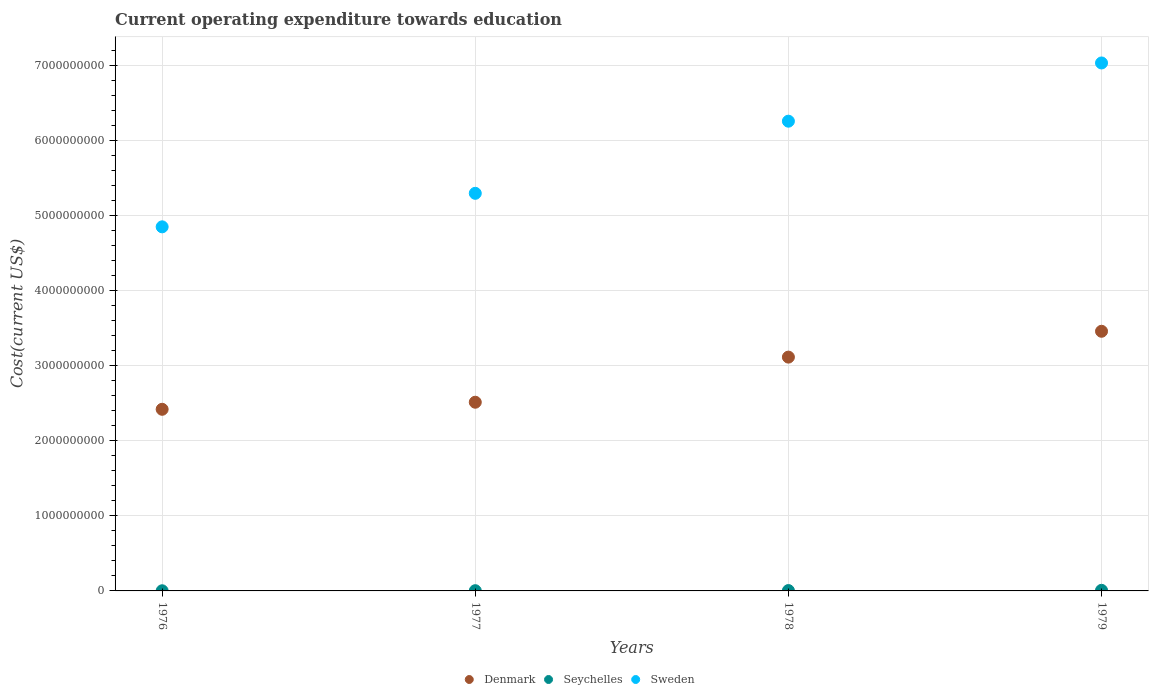What is the expenditure towards education in Seychelles in 1977?
Keep it short and to the point. 3.05e+06. Across all years, what is the maximum expenditure towards education in Denmark?
Offer a terse response. 3.46e+09. Across all years, what is the minimum expenditure towards education in Sweden?
Your answer should be very brief. 4.85e+09. In which year was the expenditure towards education in Seychelles maximum?
Give a very brief answer. 1979. In which year was the expenditure towards education in Denmark minimum?
Provide a short and direct response. 1976. What is the total expenditure towards education in Denmark in the graph?
Offer a terse response. 1.15e+1. What is the difference between the expenditure towards education in Seychelles in 1977 and that in 1979?
Provide a succinct answer. -4.85e+06. What is the difference between the expenditure towards education in Denmark in 1978 and the expenditure towards education in Sweden in 1976?
Ensure brevity in your answer.  -1.73e+09. What is the average expenditure towards education in Seychelles per year?
Keep it short and to the point. 4.40e+06. In the year 1978, what is the difference between the expenditure towards education in Seychelles and expenditure towards education in Sweden?
Provide a short and direct response. -6.25e+09. What is the ratio of the expenditure towards education in Denmark in 1976 to that in 1977?
Make the answer very short. 0.96. What is the difference between the highest and the second highest expenditure towards education in Sweden?
Offer a very short reply. 7.75e+08. What is the difference between the highest and the lowest expenditure towards education in Seychelles?
Give a very brief answer. 5.92e+06. Is the sum of the expenditure towards education in Seychelles in 1977 and 1978 greater than the maximum expenditure towards education in Denmark across all years?
Make the answer very short. No. Is the expenditure towards education in Seychelles strictly greater than the expenditure towards education in Denmark over the years?
Your response must be concise. No. Are the values on the major ticks of Y-axis written in scientific E-notation?
Your answer should be compact. No. Does the graph contain any zero values?
Keep it short and to the point. No. Does the graph contain grids?
Keep it short and to the point. Yes. Where does the legend appear in the graph?
Your answer should be compact. Bottom center. How many legend labels are there?
Provide a short and direct response. 3. What is the title of the graph?
Your response must be concise. Current operating expenditure towards education. What is the label or title of the X-axis?
Provide a short and direct response. Years. What is the label or title of the Y-axis?
Keep it short and to the point. Cost(current US$). What is the Cost(current US$) of Denmark in 1976?
Offer a very short reply. 2.42e+09. What is the Cost(current US$) in Seychelles in 1976?
Provide a short and direct response. 1.98e+06. What is the Cost(current US$) of Sweden in 1976?
Keep it short and to the point. 4.85e+09. What is the Cost(current US$) of Denmark in 1977?
Provide a short and direct response. 2.51e+09. What is the Cost(current US$) of Seychelles in 1977?
Provide a succinct answer. 3.05e+06. What is the Cost(current US$) of Sweden in 1977?
Offer a terse response. 5.29e+09. What is the Cost(current US$) of Denmark in 1978?
Provide a succinct answer. 3.11e+09. What is the Cost(current US$) of Seychelles in 1978?
Your response must be concise. 4.68e+06. What is the Cost(current US$) in Sweden in 1978?
Make the answer very short. 6.26e+09. What is the Cost(current US$) of Denmark in 1979?
Your answer should be compact. 3.46e+09. What is the Cost(current US$) of Seychelles in 1979?
Provide a succinct answer. 7.90e+06. What is the Cost(current US$) of Sweden in 1979?
Keep it short and to the point. 7.03e+09. Across all years, what is the maximum Cost(current US$) in Denmark?
Make the answer very short. 3.46e+09. Across all years, what is the maximum Cost(current US$) of Seychelles?
Your answer should be compact. 7.90e+06. Across all years, what is the maximum Cost(current US$) of Sweden?
Ensure brevity in your answer.  7.03e+09. Across all years, what is the minimum Cost(current US$) in Denmark?
Your response must be concise. 2.42e+09. Across all years, what is the minimum Cost(current US$) of Seychelles?
Give a very brief answer. 1.98e+06. Across all years, what is the minimum Cost(current US$) of Sweden?
Keep it short and to the point. 4.85e+09. What is the total Cost(current US$) of Denmark in the graph?
Provide a succinct answer. 1.15e+1. What is the total Cost(current US$) of Seychelles in the graph?
Keep it short and to the point. 1.76e+07. What is the total Cost(current US$) in Sweden in the graph?
Provide a short and direct response. 2.34e+1. What is the difference between the Cost(current US$) in Denmark in 1976 and that in 1977?
Provide a succinct answer. -9.41e+07. What is the difference between the Cost(current US$) of Seychelles in 1976 and that in 1977?
Provide a short and direct response. -1.07e+06. What is the difference between the Cost(current US$) in Sweden in 1976 and that in 1977?
Ensure brevity in your answer.  -4.46e+08. What is the difference between the Cost(current US$) in Denmark in 1976 and that in 1978?
Your answer should be compact. -6.95e+08. What is the difference between the Cost(current US$) in Seychelles in 1976 and that in 1978?
Give a very brief answer. -2.70e+06. What is the difference between the Cost(current US$) of Sweden in 1976 and that in 1978?
Your answer should be very brief. -1.41e+09. What is the difference between the Cost(current US$) of Denmark in 1976 and that in 1979?
Your answer should be compact. -1.04e+09. What is the difference between the Cost(current US$) of Seychelles in 1976 and that in 1979?
Provide a short and direct response. -5.92e+06. What is the difference between the Cost(current US$) of Sweden in 1976 and that in 1979?
Give a very brief answer. -2.18e+09. What is the difference between the Cost(current US$) in Denmark in 1977 and that in 1978?
Provide a short and direct response. -6.01e+08. What is the difference between the Cost(current US$) in Seychelles in 1977 and that in 1978?
Provide a short and direct response. -1.63e+06. What is the difference between the Cost(current US$) in Sweden in 1977 and that in 1978?
Make the answer very short. -9.61e+08. What is the difference between the Cost(current US$) of Denmark in 1977 and that in 1979?
Your answer should be very brief. -9.45e+08. What is the difference between the Cost(current US$) of Seychelles in 1977 and that in 1979?
Give a very brief answer. -4.85e+06. What is the difference between the Cost(current US$) of Sweden in 1977 and that in 1979?
Provide a succinct answer. -1.74e+09. What is the difference between the Cost(current US$) of Denmark in 1978 and that in 1979?
Give a very brief answer. -3.44e+08. What is the difference between the Cost(current US$) of Seychelles in 1978 and that in 1979?
Ensure brevity in your answer.  -3.22e+06. What is the difference between the Cost(current US$) in Sweden in 1978 and that in 1979?
Keep it short and to the point. -7.75e+08. What is the difference between the Cost(current US$) in Denmark in 1976 and the Cost(current US$) in Seychelles in 1977?
Keep it short and to the point. 2.42e+09. What is the difference between the Cost(current US$) in Denmark in 1976 and the Cost(current US$) in Sweden in 1977?
Provide a succinct answer. -2.88e+09. What is the difference between the Cost(current US$) of Seychelles in 1976 and the Cost(current US$) of Sweden in 1977?
Offer a terse response. -5.29e+09. What is the difference between the Cost(current US$) of Denmark in 1976 and the Cost(current US$) of Seychelles in 1978?
Keep it short and to the point. 2.41e+09. What is the difference between the Cost(current US$) of Denmark in 1976 and the Cost(current US$) of Sweden in 1978?
Your response must be concise. -3.84e+09. What is the difference between the Cost(current US$) of Seychelles in 1976 and the Cost(current US$) of Sweden in 1978?
Provide a succinct answer. -6.25e+09. What is the difference between the Cost(current US$) in Denmark in 1976 and the Cost(current US$) in Seychelles in 1979?
Keep it short and to the point. 2.41e+09. What is the difference between the Cost(current US$) of Denmark in 1976 and the Cost(current US$) of Sweden in 1979?
Provide a succinct answer. -4.61e+09. What is the difference between the Cost(current US$) of Seychelles in 1976 and the Cost(current US$) of Sweden in 1979?
Offer a terse response. -7.03e+09. What is the difference between the Cost(current US$) in Denmark in 1977 and the Cost(current US$) in Seychelles in 1978?
Offer a terse response. 2.51e+09. What is the difference between the Cost(current US$) of Denmark in 1977 and the Cost(current US$) of Sweden in 1978?
Your response must be concise. -3.74e+09. What is the difference between the Cost(current US$) in Seychelles in 1977 and the Cost(current US$) in Sweden in 1978?
Your response must be concise. -6.25e+09. What is the difference between the Cost(current US$) in Denmark in 1977 and the Cost(current US$) in Seychelles in 1979?
Give a very brief answer. 2.50e+09. What is the difference between the Cost(current US$) in Denmark in 1977 and the Cost(current US$) in Sweden in 1979?
Ensure brevity in your answer.  -4.52e+09. What is the difference between the Cost(current US$) in Seychelles in 1977 and the Cost(current US$) in Sweden in 1979?
Your response must be concise. -7.03e+09. What is the difference between the Cost(current US$) of Denmark in 1978 and the Cost(current US$) of Seychelles in 1979?
Make the answer very short. 3.11e+09. What is the difference between the Cost(current US$) in Denmark in 1978 and the Cost(current US$) in Sweden in 1979?
Offer a terse response. -3.92e+09. What is the difference between the Cost(current US$) in Seychelles in 1978 and the Cost(current US$) in Sweden in 1979?
Your answer should be very brief. -7.03e+09. What is the average Cost(current US$) of Denmark per year?
Your answer should be very brief. 2.88e+09. What is the average Cost(current US$) of Seychelles per year?
Offer a terse response. 4.40e+06. What is the average Cost(current US$) in Sweden per year?
Keep it short and to the point. 5.86e+09. In the year 1976, what is the difference between the Cost(current US$) of Denmark and Cost(current US$) of Seychelles?
Give a very brief answer. 2.42e+09. In the year 1976, what is the difference between the Cost(current US$) of Denmark and Cost(current US$) of Sweden?
Provide a short and direct response. -2.43e+09. In the year 1976, what is the difference between the Cost(current US$) of Seychelles and Cost(current US$) of Sweden?
Offer a terse response. -4.85e+09. In the year 1977, what is the difference between the Cost(current US$) of Denmark and Cost(current US$) of Seychelles?
Give a very brief answer. 2.51e+09. In the year 1977, what is the difference between the Cost(current US$) in Denmark and Cost(current US$) in Sweden?
Provide a short and direct response. -2.78e+09. In the year 1977, what is the difference between the Cost(current US$) in Seychelles and Cost(current US$) in Sweden?
Your answer should be very brief. -5.29e+09. In the year 1978, what is the difference between the Cost(current US$) in Denmark and Cost(current US$) in Seychelles?
Offer a very short reply. 3.11e+09. In the year 1978, what is the difference between the Cost(current US$) of Denmark and Cost(current US$) of Sweden?
Your answer should be compact. -3.14e+09. In the year 1978, what is the difference between the Cost(current US$) of Seychelles and Cost(current US$) of Sweden?
Offer a very short reply. -6.25e+09. In the year 1979, what is the difference between the Cost(current US$) of Denmark and Cost(current US$) of Seychelles?
Provide a succinct answer. 3.45e+09. In the year 1979, what is the difference between the Cost(current US$) of Denmark and Cost(current US$) of Sweden?
Your answer should be compact. -3.57e+09. In the year 1979, what is the difference between the Cost(current US$) of Seychelles and Cost(current US$) of Sweden?
Keep it short and to the point. -7.02e+09. What is the ratio of the Cost(current US$) in Denmark in 1976 to that in 1977?
Offer a very short reply. 0.96. What is the ratio of the Cost(current US$) of Seychelles in 1976 to that in 1977?
Make the answer very short. 0.65. What is the ratio of the Cost(current US$) in Sweden in 1976 to that in 1977?
Provide a short and direct response. 0.92. What is the ratio of the Cost(current US$) of Denmark in 1976 to that in 1978?
Give a very brief answer. 0.78. What is the ratio of the Cost(current US$) in Seychelles in 1976 to that in 1978?
Your answer should be compact. 0.42. What is the ratio of the Cost(current US$) in Sweden in 1976 to that in 1978?
Give a very brief answer. 0.78. What is the ratio of the Cost(current US$) in Denmark in 1976 to that in 1979?
Keep it short and to the point. 0.7. What is the ratio of the Cost(current US$) in Seychelles in 1976 to that in 1979?
Provide a short and direct response. 0.25. What is the ratio of the Cost(current US$) in Sweden in 1976 to that in 1979?
Offer a very short reply. 0.69. What is the ratio of the Cost(current US$) in Denmark in 1977 to that in 1978?
Ensure brevity in your answer.  0.81. What is the ratio of the Cost(current US$) of Seychelles in 1977 to that in 1978?
Keep it short and to the point. 0.65. What is the ratio of the Cost(current US$) in Sweden in 1977 to that in 1978?
Keep it short and to the point. 0.85. What is the ratio of the Cost(current US$) of Denmark in 1977 to that in 1979?
Give a very brief answer. 0.73. What is the ratio of the Cost(current US$) in Seychelles in 1977 to that in 1979?
Your answer should be very brief. 0.39. What is the ratio of the Cost(current US$) of Sweden in 1977 to that in 1979?
Offer a terse response. 0.75. What is the ratio of the Cost(current US$) of Denmark in 1978 to that in 1979?
Keep it short and to the point. 0.9. What is the ratio of the Cost(current US$) in Seychelles in 1978 to that in 1979?
Offer a very short reply. 0.59. What is the ratio of the Cost(current US$) of Sweden in 1978 to that in 1979?
Ensure brevity in your answer.  0.89. What is the difference between the highest and the second highest Cost(current US$) of Denmark?
Your response must be concise. 3.44e+08. What is the difference between the highest and the second highest Cost(current US$) in Seychelles?
Your answer should be very brief. 3.22e+06. What is the difference between the highest and the second highest Cost(current US$) of Sweden?
Keep it short and to the point. 7.75e+08. What is the difference between the highest and the lowest Cost(current US$) in Denmark?
Offer a very short reply. 1.04e+09. What is the difference between the highest and the lowest Cost(current US$) of Seychelles?
Provide a short and direct response. 5.92e+06. What is the difference between the highest and the lowest Cost(current US$) in Sweden?
Provide a short and direct response. 2.18e+09. 